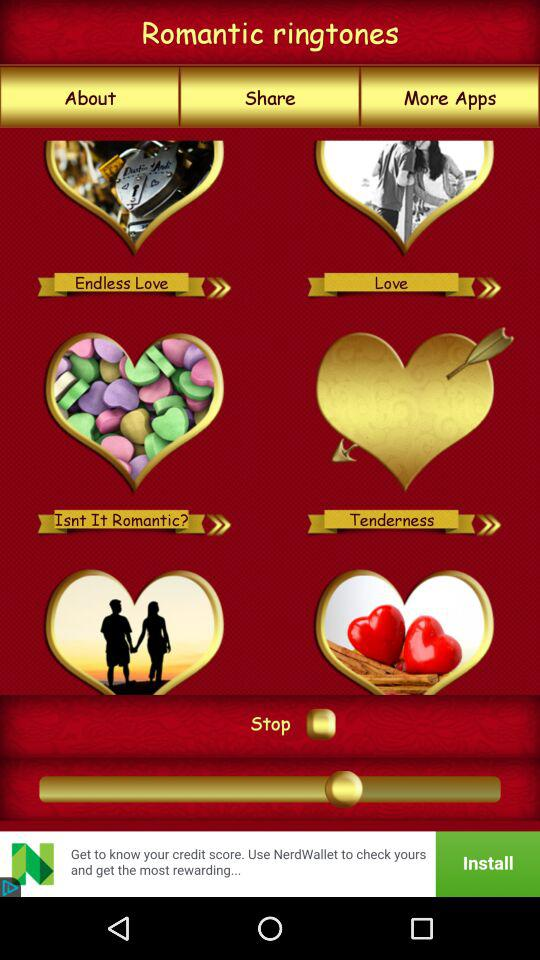What are the different ringtones in "Romantic ringtones"? The different ringtones are "Endless Love", "Love", "Isnt It Romantic?" and "Tenderness". 